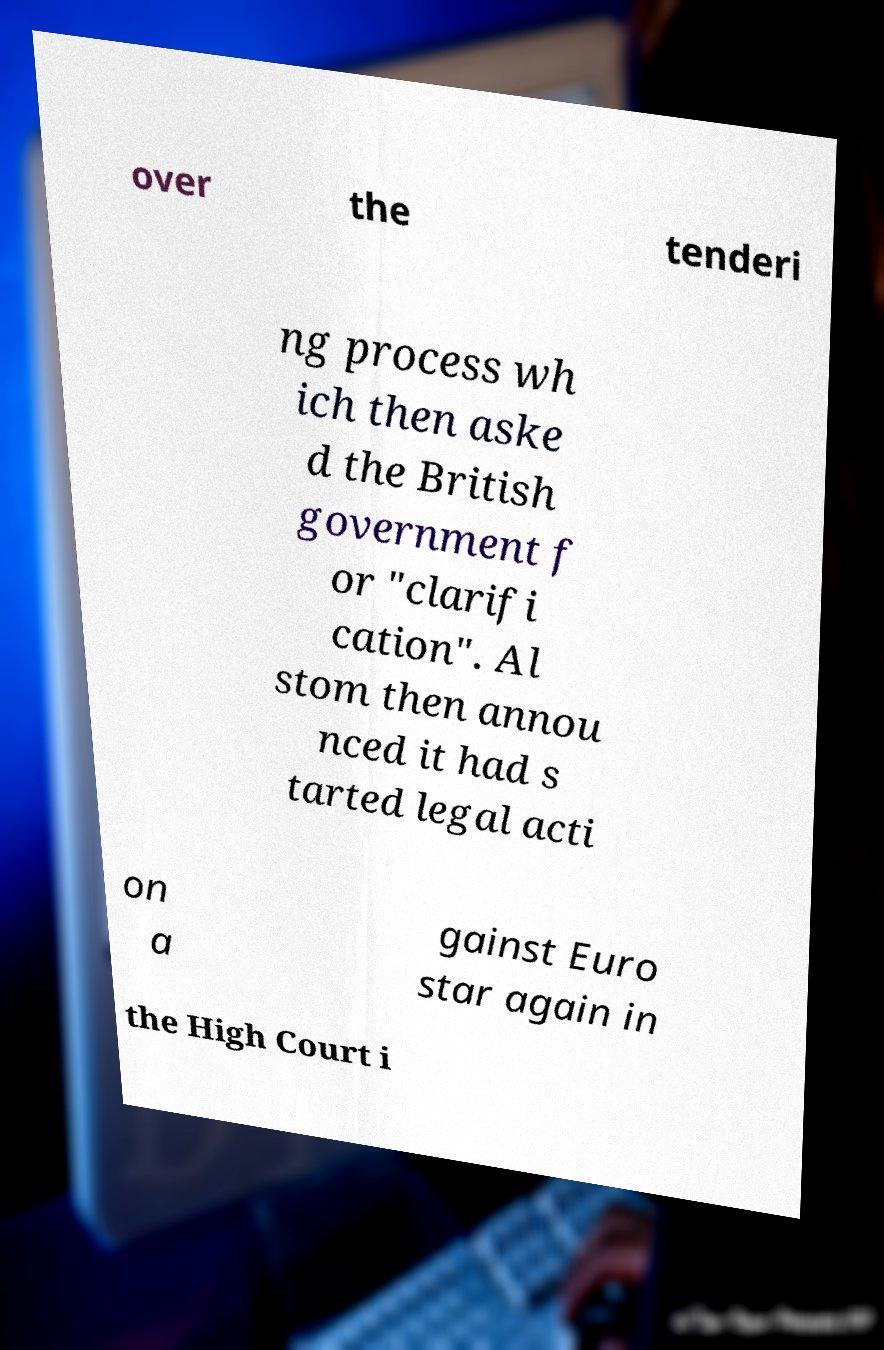For documentation purposes, I need the text within this image transcribed. Could you provide that? over the tenderi ng process wh ich then aske d the British government f or "clarifi cation". Al stom then annou nced it had s tarted legal acti on a gainst Euro star again in the High Court i 